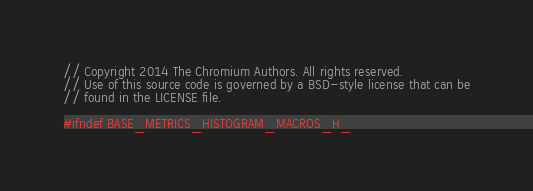Convert code to text. <code><loc_0><loc_0><loc_500><loc_500><_C_>// Copyright 2014 The Chromium Authors. All rights reserved.
// Use of this source code is governed by a BSD-style license that can be
// found in the LICENSE file.

#ifndef BASE_METRICS_HISTOGRAM_MACROS_H_</code> 